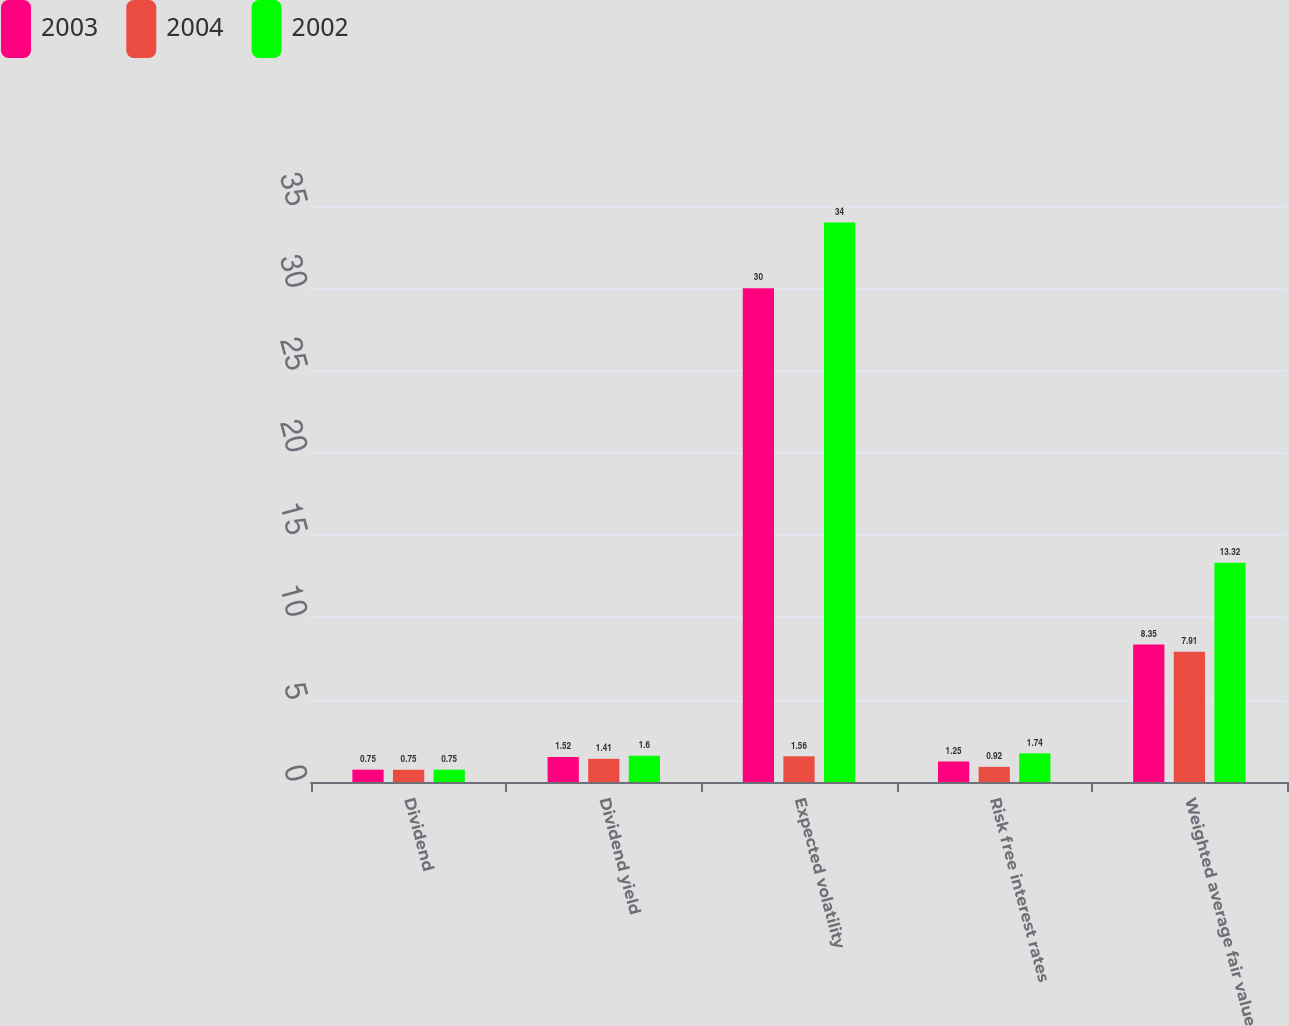Convert chart to OTSL. <chart><loc_0><loc_0><loc_500><loc_500><stacked_bar_chart><ecel><fcel>Dividend<fcel>Dividend yield<fcel>Expected volatility<fcel>Risk free interest rates<fcel>Weighted average fair value<nl><fcel>2003<fcel>0.75<fcel>1.52<fcel>30<fcel>1.25<fcel>8.35<nl><fcel>2004<fcel>0.75<fcel>1.41<fcel>1.56<fcel>0.92<fcel>7.91<nl><fcel>2002<fcel>0.75<fcel>1.6<fcel>34<fcel>1.74<fcel>13.32<nl></chart> 